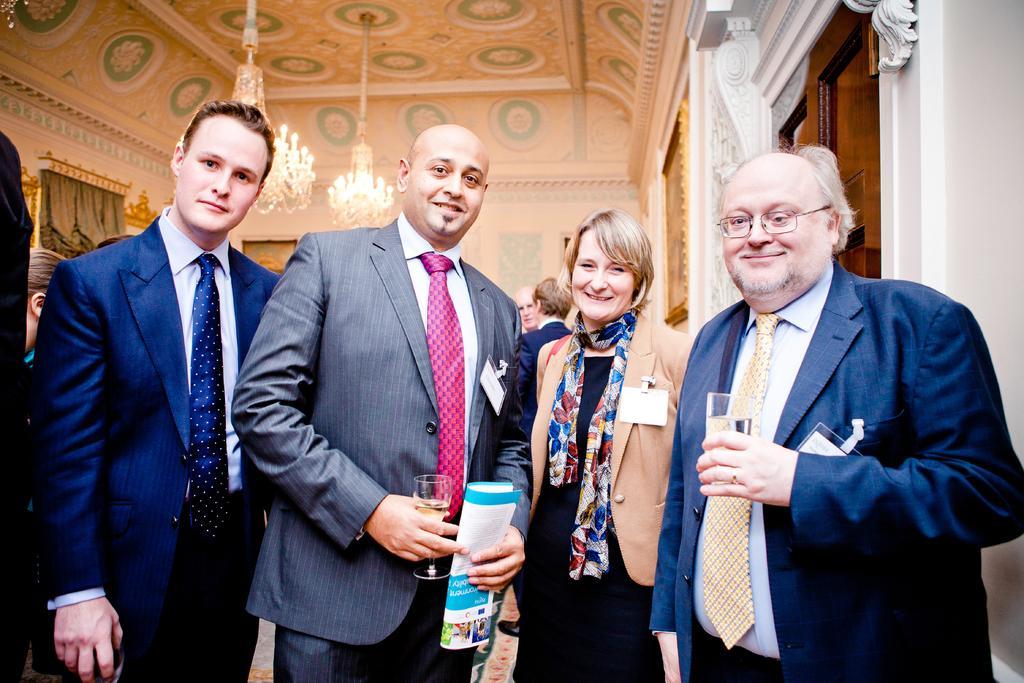Describe this image in one or two sentences. In this picture we can see four people standing, smiling and two men are holding glasses. In the background we can see some people, ceiling, chandeliers, curtains and frames. 